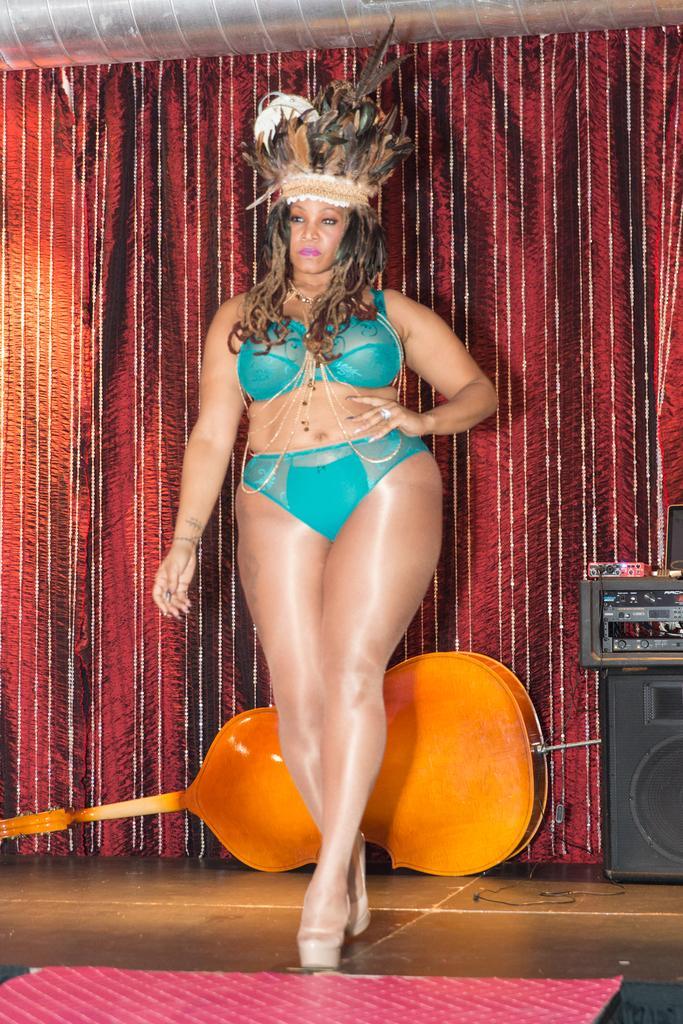Could you give a brief overview of what you see in this image? In this picture we can see a woman standing on the floor. In the background we can see a musical instrument, speaker, devices, curtain and some objects. 